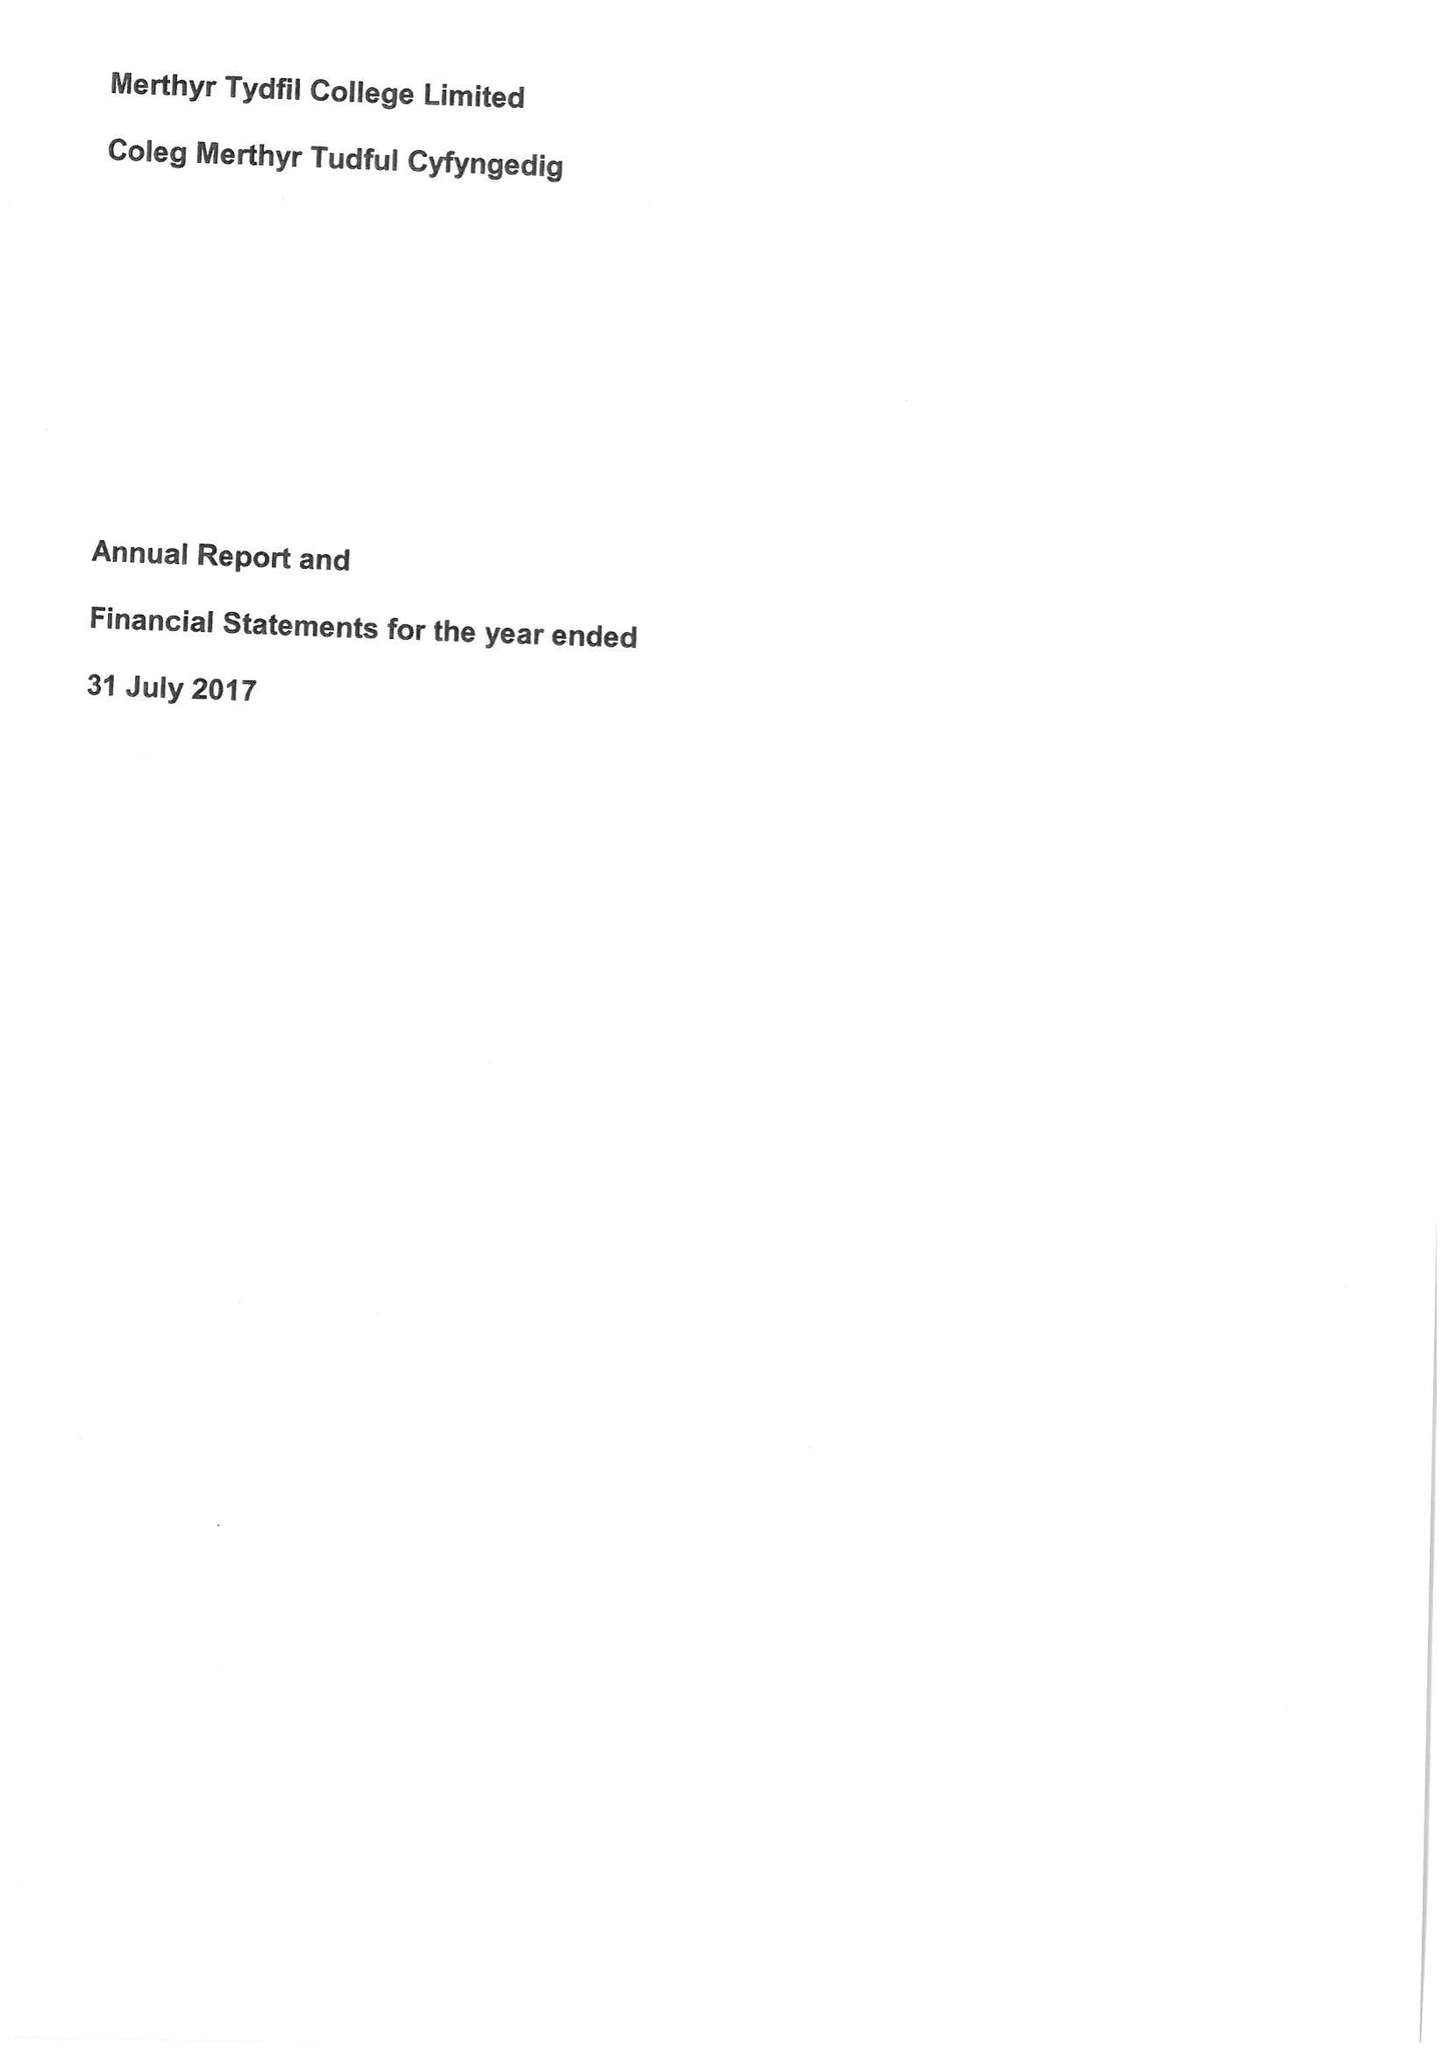What is the value for the address__street_line?
Answer the question using a single word or phrase. None 